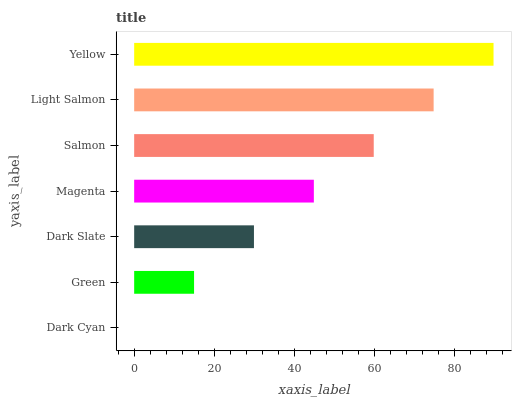Is Dark Cyan the minimum?
Answer yes or no. Yes. Is Yellow the maximum?
Answer yes or no. Yes. Is Green the minimum?
Answer yes or no. No. Is Green the maximum?
Answer yes or no. No. Is Green greater than Dark Cyan?
Answer yes or no. Yes. Is Dark Cyan less than Green?
Answer yes or no. Yes. Is Dark Cyan greater than Green?
Answer yes or no. No. Is Green less than Dark Cyan?
Answer yes or no. No. Is Magenta the high median?
Answer yes or no. Yes. Is Magenta the low median?
Answer yes or no. Yes. Is Dark Cyan the high median?
Answer yes or no. No. Is Salmon the low median?
Answer yes or no. No. 